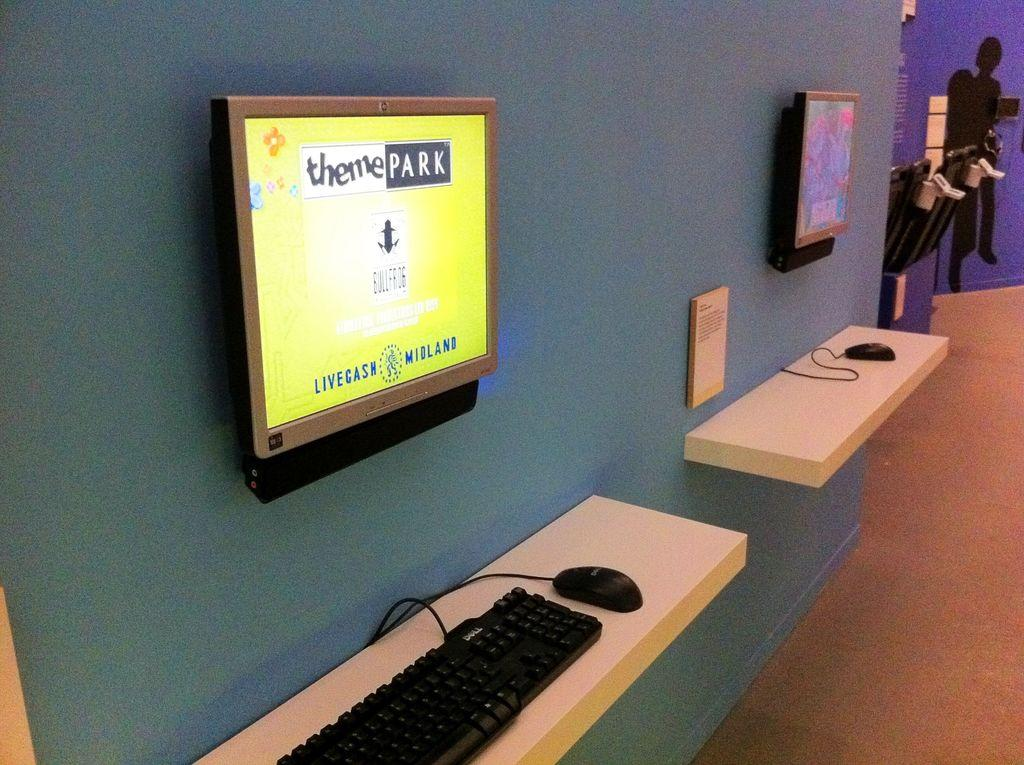<image>
Offer a succinct explanation of the picture presented. Screens are attached to a wall, one with the words theme park on it. 